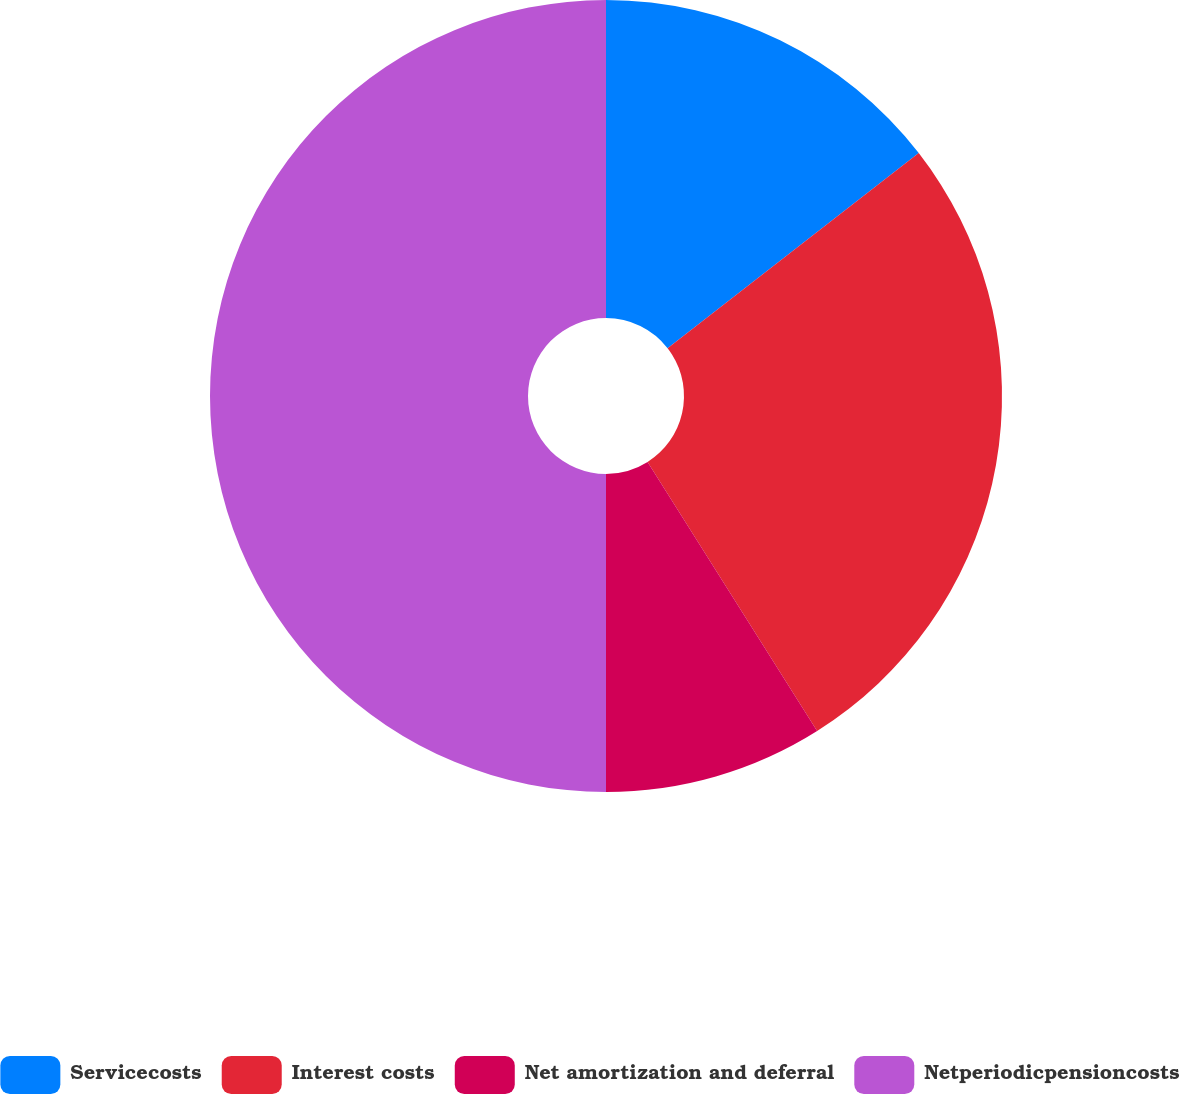Convert chart. <chart><loc_0><loc_0><loc_500><loc_500><pie_chart><fcel>Servicecosts<fcel>Interest costs<fcel>Net amortization and deferral<fcel>Netperiodicpensioncosts<nl><fcel>14.49%<fcel>26.56%<fcel>8.95%<fcel>50.0%<nl></chart> 